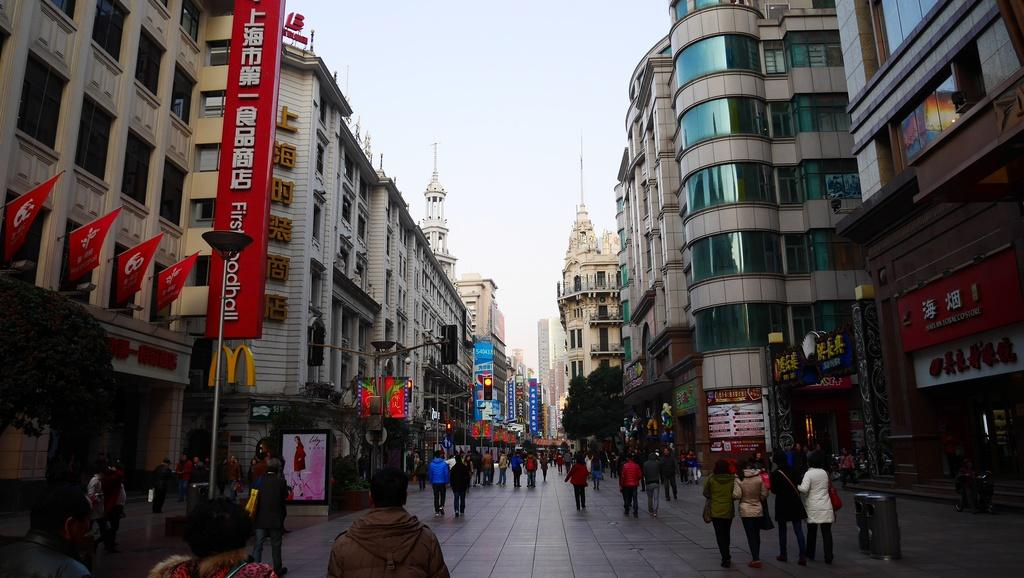Who or what can be seen in the image? There are people in the image. What else is present in the image besides people? There are posters and stalls in the image. What type of structures can be seen in the image? There are buildings in the image. What can be seen in the distance in the image? The sky is visible in the background of the image. Are there any clams visible on the dock in the image? There is no dock or clams present in the image. 